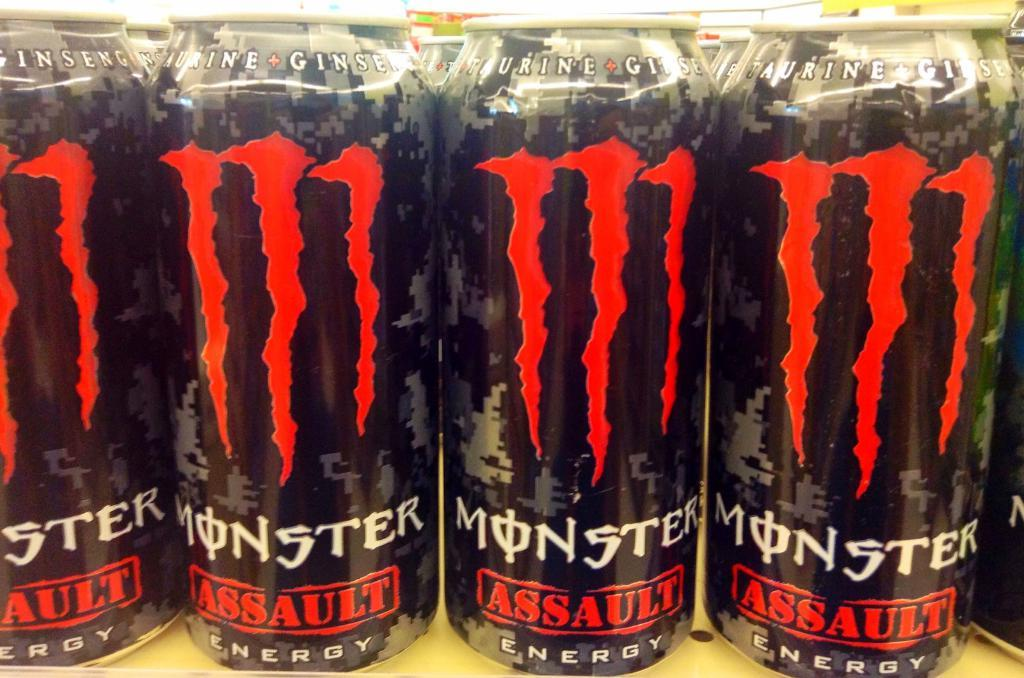Provide a one-sentence caption for the provided image. some MOnster drinks that are red and black. 